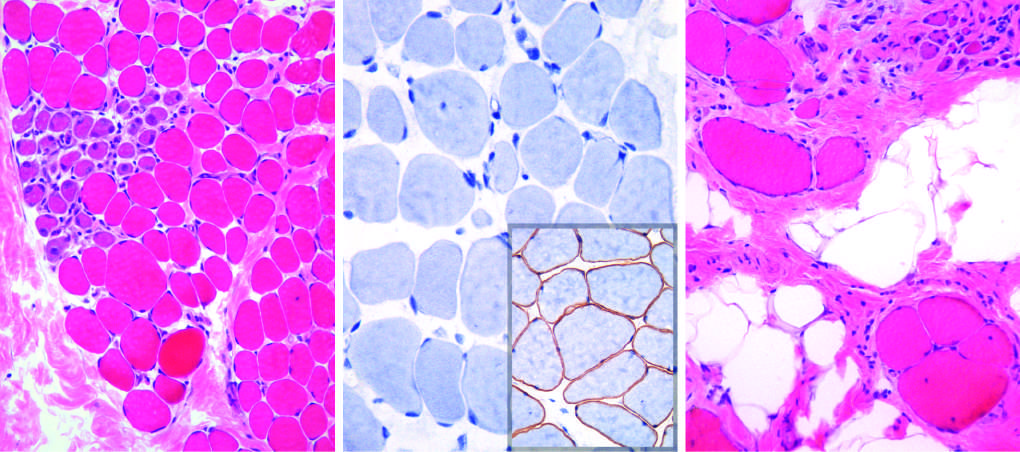what does the biopsy from the older brother illustrate?
Answer the question using a single word or phrase. Disease progression 